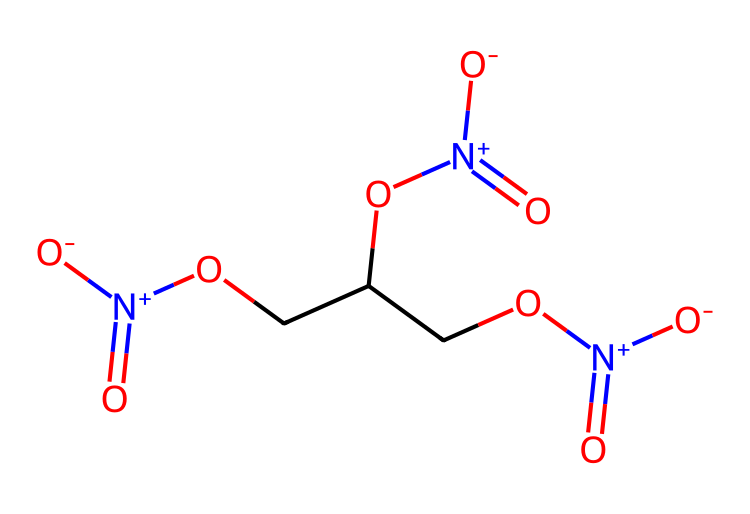How many nitrogen atoms are present in the molecule? By examining the SMILES representation, we can identify the nitrogen atoms indicated by the "N" symbols. In this case, there are three occurrences of "N" in the structure.
Answer: 3 What is the overall charge of this molecule? The molecule contains three nitrogen atoms each associated with a positive charge ([N+]), contributing to a net positive charge. However, the overall charge of the molecule must also consider the presence of three nitrate groups which have negative charges. Considering these factors, the molecule is neutral overall.
Answer: neutral How many hydroxyl (–OH) groups are in the molecule? The structure identifies hydroxyl groups represented by "O" followed by "C" and hydrogen, which will form hydroxyl groups. Inspecting the molecule shows there are two –OH groups in the chemical structure.
Answer: 2 What type of compound is nitroglycerin considered? The molecule contains multiple functional groups including nitrate (NO3) and hydroxyl (–OH) groups, which categorize it as an ester. Therefore, nitroglycerin is classified as an organic nitrate compound.
Answer: organic nitrate What is the boiling point trend related to the number of nitrate groups in this compound? The presence of more nitrate groups typically raises the boiling point due to increased intermolecular forces. Since this molecule possesses three nitrate functionalities, we can reason that the boiling point is higher compared to similar compounds with fewer nitrates.
Answer: higher boiling point How does the structure allow nitroglycerin to be used for angina treatment? The multiple nitrate groups in the structure allow for rapid conversion to nitric oxide in the body, which dilates blood vessels. This unique functional arrangement makes it effective in treating angina by improving blood flow.
Answer: vasodilation 